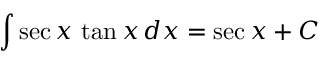Convert formula to latex. <formula><loc_0><loc_0><loc_500><loc_500>\int \sec { x } \, \tan { x } \, d x = \sec { x } + C</formula> 